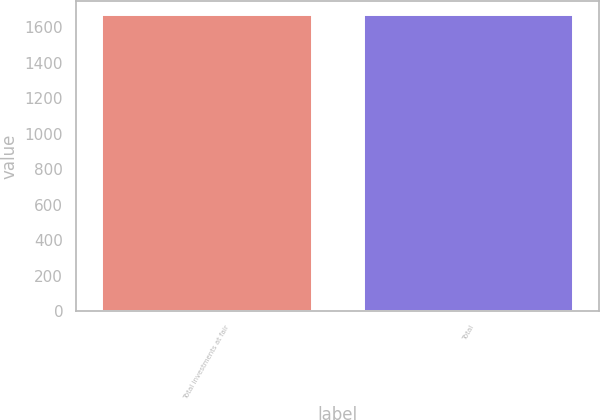<chart> <loc_0><loc_0><loc_500><loc_500><bar_chart><fcel>Total investments at fair<fcel>Total<nl><fcel>1667.3<fcel>1667.4<nl></chart> 